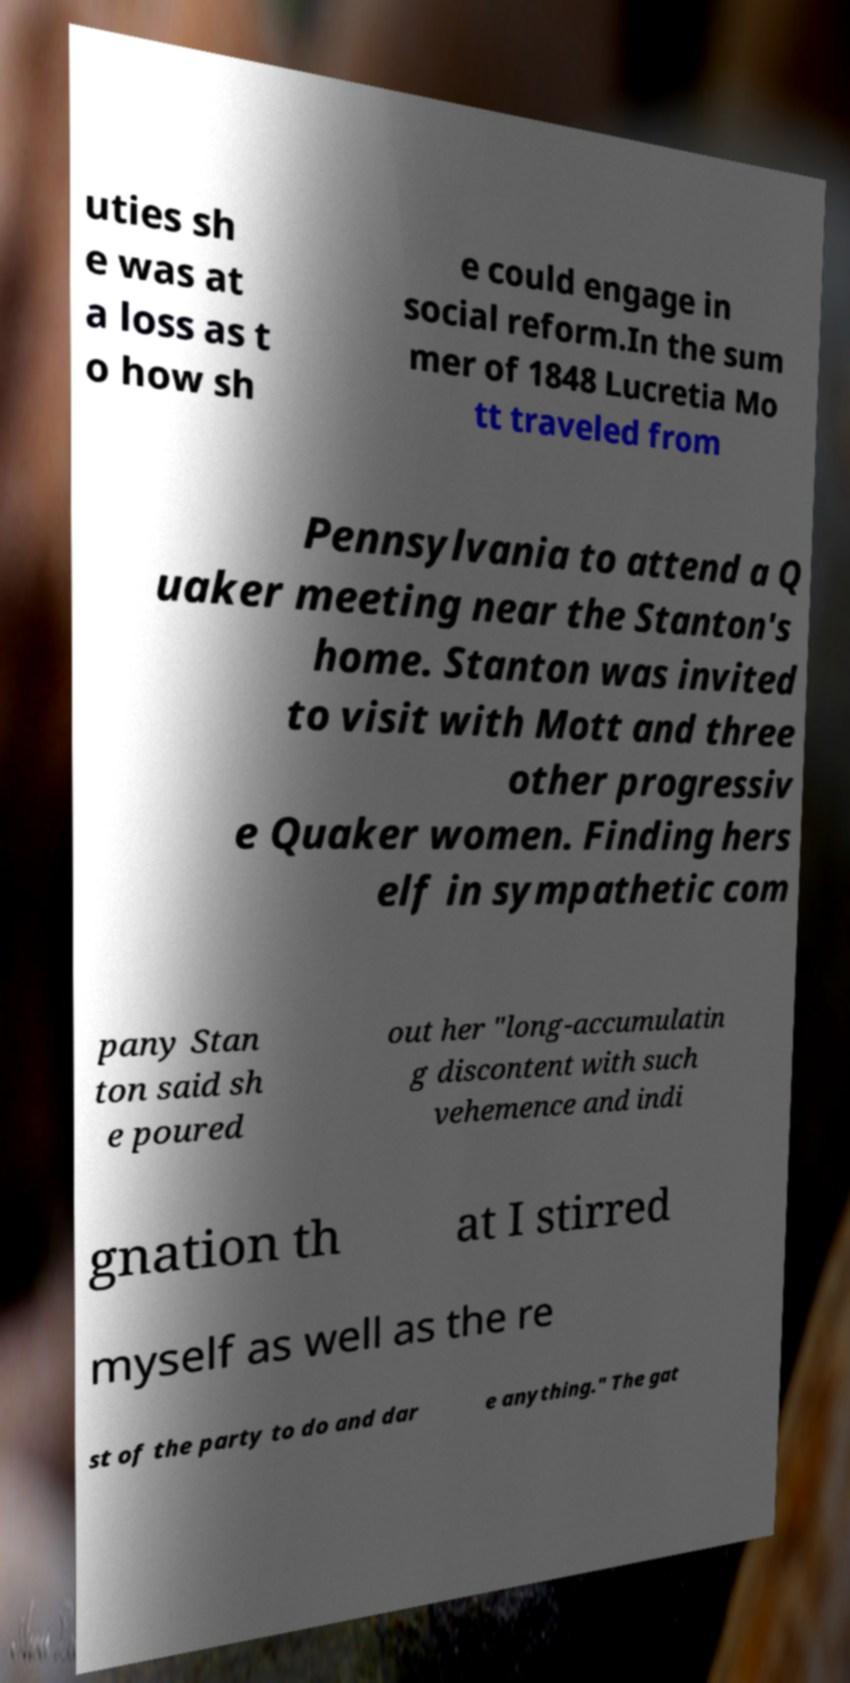For documentation purposes, I need the text within this image transcribed. Could you provide that? uties sh e was at a loss as t o how sh e could engage in social reform.In the sum mer of 1848 Lucretia Mo tt traveled from Pennsylvania to attend a Q uaker meeting near the Stanton's home. Stanton was invited to visit with Mott and three other progressiv e Quaker women. Finding hers elf in sympathetic com pany Stan ton said sh e poured out her "long-accumulatin g discontent with such vehemence and indi gnation th at I stirred myself as well as the re st of the party to do and dar e anything." The gat 